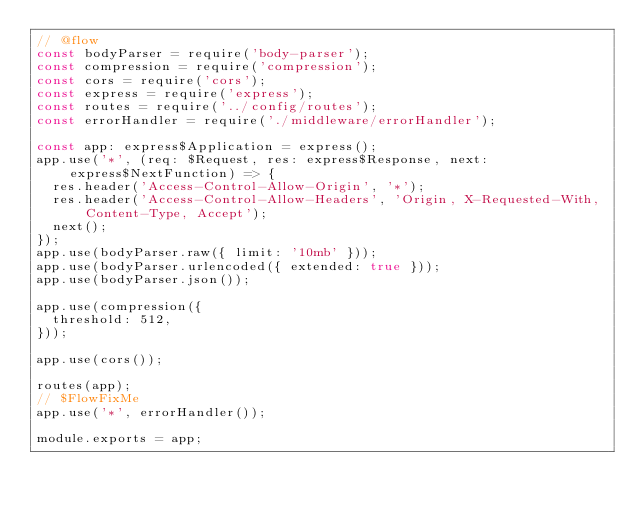Convert code to text. <code><loc_0><loc_0><loc_500><loc_500><_JavaScript_>// @flow
const bodyParser = require('body-parser');
const compression = require('compression');
const cors = require('cors');
const express = require('express');
const routes = require('../config/routes');
const errorHandler = require('./middleware/errorHandler');

const app: express$Application = express();
app.use('*', (req: $Request, res: express$Response, next: express$NextFunction) => {
  res.header('Access-Control-Allow-Origin', '*');
  res.header('Access-Control-Allow-Headers', 'Origin, X-Requested-With, Content-Type, Accept');
  next();
});
app.use(bodyParser.raw({ limit: '10mb' }));
app.use(bodyParser.urlencoded({ extended: true }));
app.use(bodyParser.json());

app.use(compression({
  threshold: 512,
}));

app.use(cors());

routes(app);
// $FlowFixMe
app.use('*', errorHandler());

module.exports = app;
</code> 